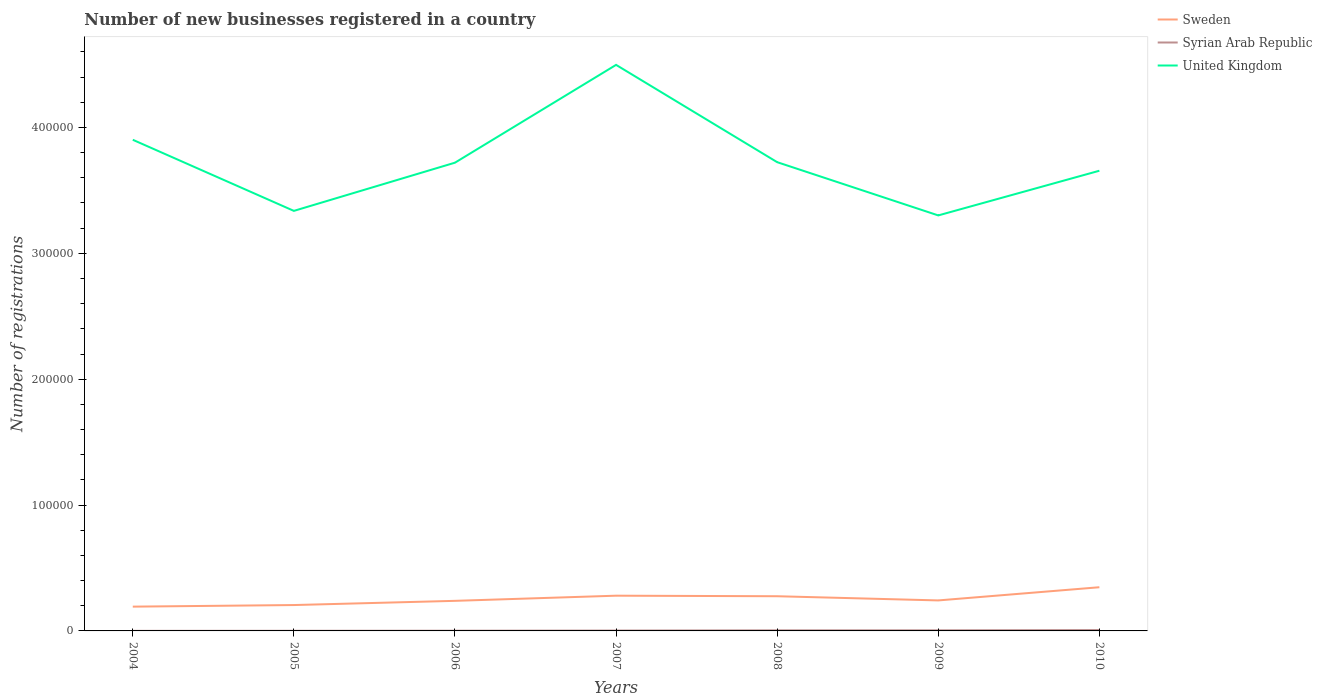Does the line corresponding to United Kingdom intersect with the line corresponding to Syrian Arab Republic?
Your answer should be very brief. No. Across all years, what is the maximum number of new businesses registered in Syrian Arab Republic?
Ensure brevity in your answer.  59. In which year was the number of new businesses registered in Sweden maximum?
Offer a terse response. 2004. What is the total number of new businesses registered in Syrian Arab Republic in the graph?
Your answer should be compact. -301. What is the difference between the highest and the second highest number of new businesses registered in United Kingdom?
Your answer should be very brief. 1.20e+05. What is the difference between the highest and the lowest number of new businesses registered in Sweden?
Provide a short and direct response. 3. How many lines are there?
Make the answer very short. 3. How many years are there in the graph?
Your answer should be compact. 7. What is the difference between two consecutive major ticks on the Y-axis?
Offer a terse response. 1.00e+05. Does the graph contain grids?
Offer a terse response. No. How many legend labels are there?
Your answer should be very brief. 3. What is the title of the graph?
Offer a terse response. Number of new businesses registered in a country. What is the label or title of the Y-axis?
Your answer should be compact. Number of registrations. What is the Number of registrations in Sweden in 2004?
Your answer should be compact. 1.93e+04. What is the Number of registrations of Syrian Arab Republic in 2004?
Ensure brevity in your answer.  59. What is the Number of registrations in United Kingdom in 2004?
Your answer should be compact. 3.90e+05. What is the Number of registrations of Sweden in 2005?
Keep it short and to the point. 2.06e+04. What is the Number of registrations of Syrian Arab Republic in 2005?
Provide a succinct answer. 114. What is the Number of registrations in United Kingdom in 2005?
Offer a very short reply. 3.34e+05. What is the Number of registrations of Sweden in 2006?
Your response must be concise. 2.39e+04. What is the Number of registrations in Syrian Arab Republic in 2006?
Give a very brief answer. 171. What is the Number of registrations of United Kingdom in 2006?
Offer a terse response. 3.72e+05. What is the Number of registrations of Sweden in 2007?
Your response must be concise. 2.80e+04. What is the Number of registrations of Syrian Arab Republic in 2007?
Offer a very short reply. 296. What is the Number of registrations of United Kingdom in 2007?
Your answer should be very brief. 4.50e+05. What is the Number of registrations in Sweden in 2008?
Ensure brevity in your answer.  2.76e+04. What is the Number of registrations of Syrian Arab Republic in 2008?
Your answer should be compact. 472. What is the Number of registrations in United Kingdom in 2008?
Your answer should be very brief. 3.72e+05. What is the Number of registrations of Sweden in 2009?
Your answer should be very brief. 2.42e+04. What is the Number of registrations of United Kingdom in 2009?
Provide a succinct answer. 3.30e+05. What is the Number of registrations in Sweden in 2010?
Offer a terse response. 3.47e+04. What is the Number of registrations in Syrian Arab Republic in 2010?
Your answer should be very brief. 713. What is the Number of registrations of United Kingdom in 2010?
Give a very brief answer. 3.66e+05. Across all years, what is the maximum Number of registrations in Sweden?
Offer a terse response. 3.47e+04. Across all years, what is the maximum Number of registrations of Syrian Arab Republic?
Offer a very short reply. 713. Across all years, what is the maximum Number of registrations in United Kingdom?
Provide a succinct answer. 4.50e+05. Across all years, what is the minimum Number of registrations of Sweden?
Provide a short and direct response. 1.93e+04. Across all years, what is the minimum Number of registrations in Syrian Arab Republic?
Your answer should be compact. 59. Across all years, what is the minimum Number of registrations of United Kingdom?
Provide a succinct answer. 3.30e+05. What is the total Number of registrations of Sweden in the graph?
Your answer should be very brief. 1.78e+05. What is the total Number of registrations of Syrian Arab Republic in the graph?
Your response must be concise. 2325. What is the total Number of registrations of United Kingdom in the graph?
Your response must be concise. 2.61e+06. What is the difference between the Number of registrations of Sweden in 2004 and that in 2005?
Your response must be concise. -1273. What is the difference between the Number of registrations in Syrian Arab Republic in 2004 and that in 2005?
Your answer should be compact. -55. What is the difference between the Number of registrations in United Kingdom in 2004 and that in 2005?
Offer a terse response. 5.65e+04. What is the difference between the Number of registrations in Sweden in 2004 and that in 2006?
Provide a short and direct response. -4606. What is the difference between the Number of registrations of Syrian Arab Republic in 2004 and that in 2006?
Offer a very short reply. -112. What is the difference between the Number of registrations of United Kingdom in 2004 and that in 2006?
Provide a short and direct response. 1.82e+04. What is the difference between the Number of registrations of Sweden in 2004 and that in 2007?
Make the answer very short. -8709. What is the difference between the Number of registrations in Syrian Arab Republic in 2004 and that in 2007?
Your answer should be very brief. -237. What is the difference between the Number of registrations in United Kingdom in 2004 and that in 2007?
Keep it short and to the point. -5.95e+04. What is the difference between the Number of registrations of Sweden in 2004 and that in 2008?
Give a very brief answer. -8267. What is the difference between the Number of registrations of Syrian Arab Republic in 2004 and that in 2008?
Make the answer very short. -413. What is the difference between the Number of registrations of United Kingdom in 2004 and that in 2008?
Your answer should be very brief. 1.78e+04. What is the difference between the Number of registrations of Sweden in 2004 and that in 2009?
Ensure brevity in your answer.  -4940. What is the difference between the Number of registrations of Syrian Arab Republic in 2004 and that in 2009?
Ensure brevity in your answer.  -441. What is the difference between the Number of registrations in United Kingdom in 2004 and that in 2009?
Your answer should be very brief. 6.01e+04. What is the difference between the Number of registrations in Sweden in 2004 and that in 2010?
Offer a terse response. -1.54e+04. What is the difference between the Number of registrations in Syrian Arab Republic in 2004 and that in 2010?
Ensure brevity in your answer.  -654. What is the difference between the Number of registrations of United Kingdom in 2004 and that in 2010?
Offer a terse response. 2.46e+04. What is the difference between the Number of registrations of Sweden in 2005 and that in 2006?
Keep it short and to the point. -3333. What is the difference between the Number of registrations in Syrian Arab Republic in 2005 and that in 2006?
Keep it short and to the point. -57. What is the difference between the Number of registrations of United Kingdom in 2005 and that in 2006?
Provide a short and direct response. -3.83e+04. What is the difference between the Number of registrations in Sweden in 2005 and that in 2007?
Your answer should be compact. -7436. What is the difference between the Number of registrations of Syrian Arab Republic in 2005 and that in 2007?
Ensure brevity in your answer.  -182. What is the difference between the Number of registrations in United Kingdom in 2005 and that in 2007?
Provide a succinct answer. -1.16e+05. What is the difference between the Number of registrations of Sweden in 2005 and that in 2008?
Your answer should be very brief. -6994. What is the difference between the Number of registrations of Syrian Arab Republic in 2005 and that in 2008?
Offer a terse response. -358. What is the difference between the Number of registrations of United Kingdom in 2005 and that in 2008?
Your response must be concise. -3.87e+04. What is the difference between the Number of registrations in Sweden in 2005 and that in 2009?
Make the answer very short. -3667. What is the difference between the Number of registrations in Syrian Arab Republic in 2005 and that in 2009?
Your response must be concise. -386. What is the difference between the Number of registrations in United Kingdom in 2005 and that in 2009?
Your response must be concise. 3600. What is the difference between the Number of registrations in Sweden in 2005 and that in 2010?
Ensure brevity in your answer.  -1.41e+04. What is the difference between the Number of registrations in Syrian Arab Republic in 2005 and that in 2010?
Your answer should be very brief. -599. What is the difference between the Number of registrations in United Kingdom in 2005 and that in 2010?
Your answer should be very brief. -3.19e+04. What is the difference between the Number of registrations of Sweden in 2006 and that in 2007?
Your response must be concise. -4103. What is the difference between the Number of registrations in Syrian Arab Republic in 2006 and that in 2007?
Keep it short and to the point. -125. What is the difference between the Number of registrations in United Kingdom in 2006 and that in 2007?
Your response must be concise. -7.77e+04. What is the difference between the Number of registrations in Sweden in 2006 and that in 2008?
Make the answer very short. -3661. What is the difference between the Number of registrations of Syrian Arab Republic in 2006 and that in 2008?
Give a very brief answer. -301. What is the difference between the Number of registrations of United Kingdom in 2006 and that in 2008?
Your answer should be very brief. -400. What is the difference between the Number of registrations of Sweden in 2006 and that in 2009?
Offer a terse response. -334. What is the difference between the Number of registrations in Syrian Arab Republic in 2006 and that in 2009?
Give a very brief answer. -329. What is the difference between the Number of registrations of United Kingdom in 2006 and that in 2009?
Provide a succinct answer. 4.19e+04. What is the difference between the Number of registrations in Sweden in 2006 and that in 2010?
Offer a very short reply. -1.08e+04. What is the difference between the Number of registrations of Syrian Arab Republic in 2006 and that in 2010?
Keep it short and to the point. -542. What is the difference between the Number of registrations in United Kingdom in 2006 and that in 2010?
Your answer should be compact. 6400. What is the difference between the Number of registrations in Sweden in 2007 and that in 2008?
Keep it short and to the point. 442. What is the difference between the Number of registrations in Syrian Arab Republic in 2007 and that in 2008?
Your answer should be compact. -176. What is the difference between the Number of registrations of United Kingdom in 2007 and that in 2008?
Your response must be concise. 7.73e+04. What is the difference between the Number of registrations of Sweden in 2007 and that in 2009?
Your answer should be very brief. 3769. What is the difference between the Number of registrations of Syrian Arab Republic in 2007 and that in 2009?
Your response must be concise. -204. What is the difference between the Number of registrations in United Kingdom in 2007 and that in 2009?
Give a very brief answer. 1.20e+05. What is the difference between the Number of registrations in Sweden in 2007 and that in 2010?
Offer a terse response. -6711. What is the difference between the Number of registrations of Syrian Arab Republic in 2007 and that in 2010?
Keep it short and to the point. -417. What is the difference between the Number of registrations in United Kingdom in 2007 and that in 2010?
Keep it short and to the point. 8.41e+04. What is the difference between the Number of registrations in Sweden in 2008 and that in 2009?
Give a very brief answer. 3327. What is the difference between the Number of registrations of United Kingdom in 2008 and that in 2009?
Give a very brief answer. 4.23e+04. What is the difference between the Number of registrations in Sweden in 2008 and that in 2010?
Offer a terse response. -7153. What is the difference between the Number of registrations in Syrian Arab Republic in 2008 and that in 2010?
Your answer should be very brief. -241. What is the difference between the Number of registrations of United Kingdom in 2008 and that in 2010?
Ensure brevity in your answer.  6800. What is the difference between the Number of registrations of Sweden in 2009 and that in 2010?
Your answer should be very brief. -1.05e+04. What is the difference between the Number of registrations in Syrian Arab Republic in 2009 and that in 2010?
Provide a short and direct response. -213. What is the difference between the Number of registrations of United Kingdom in 2009 and that in 2010?
Give a very brief answer. -3.55e+04. What is the difference between the Number of registrations in Sweden in 2004 and the Number of registrations in Syrian Arab Republic in 2005?
Make the answer very short. 1.92e+04. What is the difference between the Number of registrations in Sweden in 2004 and the Number of registrations in United Kingdom in 2005?
Make the answer very short. -3.14e+05. What is the difference between the Number of registrations in Syrian Arab Republic in 2004 and the Number of registrations in United Kingdom in 2005?
Offer a very short reply. -3.34e+05. What is the difference between the Number of registrations in Sweden in 2004 and the Number of registrations in Syrian Arab Republic in 2006?
Your answer should be compact. 1.91e+04. What is the difference between the Number of registrations in Sweden in 2004 and the Number of registrations in United Kingdom in 2006?
Offer a very short reply. -3.53e+05. What is the difference between the Number of registrations in Syrian Arab Republic in 2004 and the Number of registrations in United Kingdom in 2006?
Your answer should be very brief. -3.72e+05. What is the difference between the Number of registrations in Sweden in 2004 and the Number of registrations in Syrian Arab Republic in 2007?
Your answer should be compact. 1.90e+04. What is the difference between the Number of registrations of Sweden in 2004 and the Number of registrations of United Kingdom in 2007?
Give a very brief answer. -4.30e+05. What is the difference between the Number of registrations of Syrian Arab Republic in 2004 and the Number of registrations of United Kingdom in 2007?
Offer a terse response. -4.50e+05. What is the difference between the Number of registrations in Sweden in 2004 and the Number of registrations in Syrian Arab Republic in 2008?
Ensure brevity in your answer.  1.88e+04. What is the difference between the Number of registrations in Sweden in 2004 and the Number of registrations in United Kingdom in 2008?
Your answer should be very brief. -3.53e+05. What is the difference between the Number of registrations in Syrian Arab Republic in 2004 and the Number of registrations in United Kingdom in 2008?
Offer a very short reply. -3.72e+05. What is the difference between the Number of registrations of Sweden in 2004 and the Number of registrations of Syrian Arab Republic in 2009?
Provide a succinct answer. 1.88e+04. What is the difference between the Number of registrations in Sweden in 2004 and the Number of registrations in United Kingdom in 2009?
Offer a terse response. -3.11e+05. What is the difference between the Number of registrations of Syrian Arab Republic in 2004 and the Number of registrations of United Kingdom in 2009?
Provide a succinct answer. -3.30e+05. What is the difference between the Number of registrations in Sweden in 2004 and the Number of registrations in Syrian Arab Republic in 2010?
Make the answer very short. 1.86e+04. What is the difference between the Number of registrations of Sweden in 2004 and the Number of registrations of United Kingdom in 2010?
Keep it short and to the point. -3.46e+05. What is the difference between the Number of registrations of Syrian Arab Republic in 2004 and the Number of registrations of United Kingdom in 2010?
Offer a terse response. -3.66e+05. What is the difference between the Number of registrations of Sweden in 2005 and the Number of registrations of Syrian Arab Republic in 2006?
Offer a terse response. 2.04e+04. What is the difference between the Number of registrations of Sweden in 2005 and the Number of registrations of United Kingdom in 2006?
Offer a terse response. -3.51e+05. What is the difference between the Number of registrations in Syrian Arab Republic in 2005 and the Number of registrations in United Kingdom in 2006?
Make the answer very short. -3.72e+05. What is the difference between the Number of registrations in Sweden in 2005 and the Number of registrations in Syrian Arab Republic in 2007?
Keep it short and to the point. 2.03e+04. What is the difference between the Number of registrations in Sweden in 2005 and the Number of registrations in United Kingdom in 2007?
Make the answer very short. -4.29e+05. What is the difference between the Number of registrations in Syrian Arab Republic in 2005 and the Number of registrations in United Kingdom in 2007?
Provide a succinct answer. -4.50e+05. What is the difference between the Number of registrations of Sweden in 2005 and the Number of registrations of Syrian Arab Republic in 2008?
Your response must be concise. 2.01e+04. What is the difference between the Number of registrations of Sweden in 2005 and the Number of registrations of United Kingdom in 2008?
Give a very brief answer. -3.52e+05. What is the difference between the Number of registrations in Syrian Arab Republic in 2005 and the Number of registrations in United Kingdom in 2008?
Offer a terse response. -3.72e+05. What is the difference between the Number of registrations of Sweden in 2005 and the Number of registrations of Syrian Arab Republic in 2009?
Make the answer very short. 2.01e+04. What is the difference between the Number of registrations in Sweden in 2005 and the Number of registrations in United Kingdom in 2009?
Provide a succinct answer. -3.10e+05. What is the difference between the Number of registrations in Syrian Arab Republic in 2005 and the Number of registrations in United Kingdom in 2009?
Ensure brevity in your answer.  -3.30e+05. What is the difference between the Number of registrations in Sweden in 2005 and the Number of registrations in Syrian Arab Republic in 2010?
Offer a terse response. 1.98e+04. What is the difference between the Number of registrations in Sweden in 2005 and the Number of registrations in United Kingdom in 2010?
Offer a terse response. -3.45e+05. What is the difference between the Number of registrations in Syrian Arab Republic in 2005 and the Number of registrations in United Kingdom in 2010?
Offer a very short reply. -3.65e+05. What is the difference between the Number of registrations in Sweden in 2006 and the Number of registrations in Syrian Arab Republic in 2007?
Your answer should be very brief. 2.36e+04. What is the difference between the Number of registrations in Sweden in 2006 and the Number of registrations in United Kingdom in 2007?
Keep it short and to the point. -4.26e+05. What is the difference between the Number of registrations in Syrian Arab Republic in 2006 and the Number of registrations in United Kingdom in 2007?
Provide a succinct answer. -4.50e+05. What is the difference between the Number of registrations of Sweden in 2006 and the Number of registrations of Syrian Arab Republic in 2008?
Give a very brief answer. 2.34e+04. What is the difference between the Number of registrations in Sweden in 2006 and the Number of registrations in United Kingdom in 2008?
Your answer should be compact. -3.49e+05. What is the difference between the Number of registrations in Syrian Arab Republic in 2006 and the Number of registrations in United Kingdom in 2008?
Ensure brevity in your answer.  -3.72e+05. What is the difference between the Number of registrations of Sweden in 2006 and the Number of registrations of Syrian Arab Republic in 2009?
Make the answer very short. 2.34e+04. What is the difference between the Number of registrations of Sweden in 2006 and the Number of registrations of United Kingdom in 2009?
Your response must be concise. -3.06e+05. What is the difference between the Number of registrations in Syrian Arab Republic in 2006 and the Number of registrations in United Kingdom in 2009?
Provide a short and direct response. -3.30e+05. What is the difference between the Number of registrations of Sweden in 2006 and the Number of registrations of Syrian Arab Republic in 2010?
Ensure brevity in your answer.  2.32e+04. What is the difference between the Number of registrations of Sweden in 2006 and the Number of registrations of United Kingdom in 2010?
Keep it short and to the point. -3.42e+05. What is the difference between the Number of registrations in Syrian Arab Republic in 2006 and the Number of registrations in United Kingdom in 2010?
Provide a short and direct response. -3.65e+05. What is the difference between the Number of registrations in Sweden in 2007 and the Number of registrations in Syrian Arab Republic in 2008?
Your answer should be compact. 2.75e+04. What is the difference between the Number of registrations of Sweden in 2007 and the Number of registrations of United Kingdom in 2008?
Offer a terse response. -3.44e+05. What is the difference between the Number of registrations of Syrian Arab Republic in 2007 and the Number of registrations of United Kingdom in 2008?
Your answer should be compact. -3.72e+05. What is the difference between the Number of registrations of Sweden in 2007 and the Number of registrations of Syrian Arab Republic in 2009?
Provide a short and direct response. 2.75e+04. What is the difference between the Number of registrations of Sweden in 2007 and the Number of registrations of United Kingdom in 2009?
Provide a succinct answer. -3.02e+05. What is the difference between the Number of registrations of Syrian Arab Republic in 2007 and the Number of registrations of United Kingdom in 2009?
Offer a terse response. -3.30e+05. What is the difference between the Number of registrations of Sweden in 2007 and the Number of registrations of Syrian Arab Republic in 2010?
Offer a very short reply. 2.73e+04. What is the difference between the Number of registrations of Sweden in 2007 and the Number of registrations of United Kingdom in 2010?
Provide a short and direct response. -3.38e+05. What is the difference between the Number of registrations of Syrian Arab Republic in 2007 and the Number of registrations of United Kingdom in 2010?
Give a very brief answer. -3.65e+05. What is the difference between the Number of registrations in Sweden in 2008 and the Number of registrations in Syrian Arab Republic in 2009?
Provide a succinct answer. 2.71e+04. What is the difference between the Number of registrations of Sweden in 2008 and the Number of registrations of United Kingdom in 2009?
Your answer should be very brief. -3.03e+05. What is the difference between the Number of registrations of Syrian Arab Republic in 2008 and the Number of registrations of United Kingdom in 2009?
Your answer should be compact. -3.30e+05. What is the difference between the Number of registrations of Sweden in 2008 and the Number of registrations of Syrian Arab Republic in 2010?
Offer a very short reply. 2.68e+04. What is the difference between the Number of registrations of Sweden in 2008 and the Number of registrations of United Kingdom in 2010?
Your response must be concise. -3.38e+05. What is the difference between the Number of registrations of Syrian Arab Republic in 2008 and the Number of registrations of United Kingdom in 2010?
Keep it short and to the point. -3.65e+05. What is the difference between the Number of registrations in Sweden in 2009 and the Number of registrations in Syrian Arab Republic in 2010?
Give a very brief answer. 2.35e+04. What is the difference between the Number of registrations of Sweden in 2009 and the Number of registrations of United Kingdom in 2010?
Provide a short and direct response. -3.41e+05. What is the difference between the Number of registrations of Syrian Arab Republic in 2009 and the Number of registrations of United Kingdom in 2010?
Give a very brief answer. -3.65e+05. What is the average Number of registrations of Sweden per year?
Your response must be concise. 2.55e+04. What is the average Number of registrations in Syrian Arab Republic per year?
Provide a succinct answer. 332.14. What is the average Number of registrations of United Kingdom per year?
Ensure brevity in your answer.  3.73e+05. In the year 2004, what is the difference between the Number of registrations in Sweden and Number of registrations in Syrian Arab Republic?
Offer a very short reply. 1.92e+04. In the year 2004, what is the difference between the Number of registrations in Sweden and Number of registrations in United Kingdom?
Give a very brief answer. -3.71e+05. In the year 2004, what is the difference between the Number of registrations of Syrian Arab Republic and Number of registrations of United Kingdom?
Provide a succinct answer. -3.90e+05. In the year 2005, what is the difference between the Number of registrations of Sweden and Number of registrations of Syrian Arab Republic?
Offer a terse response. 2.04e+04. In the year 2005, what is the difference between the Number of registrations in Sweden and Number of registrations in United Kingdom?
Give a very brief answer. -3.13e+05. In the year 2005, what is the difference between the Number of registrations of Syrian Arab Republic and Number of registrations of United Kingdom?
Keep it short and to the point. -3.34e+05. In the year 2006, what is the difference between the Number of registrations of Sweden and Number of registrations of Syrian Arab Republic?
Make the answer very short. 2.37e+04. In the year 2006, what is the difference between the Number of registrations of Sweden and Number of registrations of United Kingdom?
Ensure brevity in your answer.  -3.48e+05. In the year 2006, what is the difference between the Number of registrations in Syrian Arab Republic and Number of registrations in United Kingdom?
Keep it short and to the point. -3.72e+05. In the year 2007, what is the difference between the Number of registrations of Sweden and Number of registrations of Syrian Arab Republic?
Offer a terse response. 2.77e+04. In the year 2007, what is the difference between the Number of registrations of Sweden and Number of registrations of United Kingdom?
Keep it short and to the point. -4.22e+05. In the year 2007, what is the difference between the Number of registrations of Syrian Arab Republic and Number of registrations of United Kingdom?
Provide a short and direct response. -4.49e+05. In the year 2008, what is the difference between the Number of registrations in Sweden and Number of registrations in Syrian Arab Republic?
Offer a terse response. 2.71e+04. In the year 2008, what is the difference between the Number of registrations of Sweden and Number of registrations of United Kingdom?
Give a very brief answer. -3.45e+05. In the year 2008, what is the difference between the Number of registrations of Syrian Arab Republic and Number of registrations of United Kingdom?
Your answer should be very brief. -3.72e+05. In the year 2009, what is the difference between the Number of registrations in Sweden and Number of registrations in Syrian Arab Republic?
Your answer should be compact. 2.37e+04. In the year 2009, what is the difference between the Number of registrations in Sweden and Number of registrations in United Kingdom?
Make the answer very short. -3.06e+05. In the year 2009, what is the difference between the Number of registrations in Syrian Arab Republic and Number of registrations in United Kingdom?
Your answer should be very brief. -3.30e+05. In the year 2010, what is the difference between the Number of registrations in Sweden and Number of registrations in Syrian Arab Republic?
Your response must be concise. 3.40e+04. In the year 2010, what is the difference between the Number of registrations in Sweden and Number of registrations in United Kingdom?
Keep it short and to the point. -3.31e+05. In the year 2010, what is the difference between the Number of registrations of Syrian Arab Republic and Number of registrations of United Kingdom?
Keep it short and to the point. -3.65e+05. What is the ratio of the Number of registrations of Sweden in 2004 to that in 2005?
Your response must be concise. 0.94. What is the ratio of the Number of registrations in Syrian Arab Republic in 2004 to that in 2005?
Make the answer very short. 0.52. What is the ratio of the Number of registrations in United Kingdom in 2004 to that in 2005?
Ensure brevity in your answer.  1.17. What is the ratio of the Number of registrations in Sweden in 2004 to that in 2006?
Keep it short and to the point. 0.81. What is the ratio of the Number of registrations of Syrian Arab Republic in 2004 to that in 2006?
Make the answer very short. 0.34. What is the ratio of the Number of registrations in United Kingdom in 2004 to that in 2006?
Give a very brief answer. 1.05. What is the ratio of the Number of registrations in Sweden in 2004 to that in 2007?
Provide a succinct answer. 0.69. What is the ratio of the Number of registrations in Syrian Arab Republic in 2004 to that in 2007?
Make the answer very short. 0.2. What is the ratio of the Number of registrations in United Kingdom in 2004 to that in 2007?
Offer a terse response. 0.87. What is the ratio of the Number of registrations of Sweden in 2004 to that in 2008?
Ensure brevity in your answer.  0.7. What is the ratio of the Number of registrations in Syrian Arab Republic in 2004 to that in 2008?
Make the answer very short. 0.12. What is the ratio of the Number of registrations in United Kingdom in 2004 to that in 2008?
Provide a short and direct response. 1.05. What is the ratio of the Number of registrations in Sweden in 2004 to that in 2009?
Keep it short and to the point. 0.8. What is the ratio of the Number of registrations of Syrian Arab Republic in 2004 to that in 2009?
Your answer should be compact. 0.12. What is the ratio of the Number of registrations in United Kingdom in 2004 to that in 2009?
Give a very brief answer. 1.18. What is the ratio of the Number of registrations of Sweden in 2004 to that in 2010?
Give a very brief answer. 0.56. What is the ratio of the Number of registrations of Syrian Arab Republic in 2004 to that in 2010?
Your answer should be compact. 0.08. What is the ratio of the Number of registrations of United Kingdom in 2004 to that in 2010?
Your answer should be compact. 1.07. What is the ratio of the Number of registrations in Sweden in 2005 to that in 2006?
Provide a succinct answer. 0.86. What is the ratio of the Number of registrations in United Kingdom in 2005 to that in 2006?
Offer a terse response. 0.9. What is the ratio of the Number of registrations in Sweden in 2005 to that in 2007?
Offer a terse response. 0.73. What is the ratio of the Number of registrations in Syrian Arab Republic in 2005 to that in 2007?
Your response must be concise. 0.39. What is the ratio of the Number of registrations in United Kingdom in 2005 to that in 2007?
Provide a succinct answer. 0.74. What is the ratio of the Number of registrations in Sweden in 2005 to that in 2008?
Offer a terse response. 0.75. What is the ratio of the Number of registrations in Syrian Arab Republic in 2005 to that in 2008?
Keep it short and to the point. 0.24. What is the ratio of the Number of registrations in United Kingdom in 2005 to that in 2008?
Keep it short and to the point. 0.9. What is the ratio of the Number of registrations in Sweden in 2005 to that in 2009?
Provide a short and direct response. 0.85. What is the ratio of the Number of registrations in Syrian Arab Republic in 2005 to that in 2009?
Keep it short and to the point. 0.23. What is the ratio of the Number of registrations in United Kingdom in 2005 to that in 2009?
Make the answer very short. 1.01. What is the ratio of the Number of registrations in Sweden in 2005 to that in 2010?
Keep it short and to the point. 0.59. What is the ratio of the Number of registrations in Syrian Arab Republic in 2005 to that in 2010?
Your answer should be very brief. 0.16. What is the ratio of the Number of registrations in United Kingdom in 2005 to that in 2010?
Your response must be concise. 0.91. What is the ratio of the Number of registrations in Sweden in 2006 to that in 2007?
Provide a short and direct response. 0.85. What is the ratio of the Number of registrations of Syrian Arab Republic in 2006 to that in 2007?
Provide a succinct answer. 0.58. What is the ratio of the Number of registrations in United Kingdom in 2006 to that in 2007?
Provide a short and direct response. 0.83. What is the ratio of the Number of registrations in Sweden in 2006 to that in 2008?
Give a very brief answer. 0.87. What is the ratio of the Number of registrations in Syrian Arab Republic in 2006 to that in 2008?
Provide a short and direct response. 0.36. What is the ratio of the Number of registrations of United Kingdom in 2006 to that in 2008?
Offer a very short reply. 1. What is the ratio of the Number of registrations in Sweden in 2006 to that in 2009?
Your response must be concise. 0.99. What is the ratio of the Number of registrations in Syrian Arab Republic in 2006 to that in 2009?
Your answer should be very brief. 0.34. What is the ratio of the Number of registrations in United Kingdom in 2006 to that in 2009?
Your answer should be very brief. 1.13. What is the ratio of the Number of registrations of Sweden in 2006 to that in 2010?
Provide a succinct answer. 0.69. What is the ratio of the Number of registrations in Syrian Arab Republic in 2006 to that in 2010?
Provide a succinct answer. 0.24. What is the ratio of the Number of registrations in United Kingdom in 2006 to that in 2010?
Keep it short and to the point. 1.02. What is the ratio of the Number of registrations of Sweden in 2007 to that in 2008?
Keep it short and to the point. 1.02. What is the ratio of the Number of registrations of Syrian Arab Republic in 2007 to that in 2008?
Your answer should be compact. 0.63. What is the ratio of the Number of registrations in United Kingdom in 2007 to that in 2008?
Provide a succinct answer. 1.21. What is the ratio of the Number of registrations in Sweden in 2007 to that in 2009?
Your answer should be compact. 1.16. What is the ratio of the Number of registrations of Syrian Arab Republic in 2007 to that in 2009?
Provide a short and direct response. 0.59. What is the ratio of the Number of registrations in United Kingdom in 2007 to that in 2009?
Provide a short and direct response. 1.36. What is the ratio of the Number of registrations of Sweden in 2007 to that in 2010?
Offer a terse response. 0.81. What is the ratio of the Number of registrations in Syrian Arab Republic in 2007 to that in 2010?
Provide a short and direct response. 0.42. What is the ratio of the Number of registrations in United Kingdom in 2007 to that in 2010?
Make the answer very short. 1.23. What is the ratio of the Number of registrations of Sweden in 2008 to that in 2009?
Offer a very short reply. 1.14. What is the ratio of the Number of registrations of Syrian Arab Republic in 2008 to that in 2009?
Provide a short and direct response. 0.94. What is the ratio of the Number of registrations in United Kingdom in 2008 to that in 2009?
Offer a terse response. 1.13. What is the ratio of the Number of registrations in Sweden in 2008 to that in 2010?
Offer a terse response. 0.79. What is the ratio of the Number of registrations of Syrian Arab Republic in 2008 to that in 2010?
Offer a terse response. 0.66. What is the ratio of the Number of registrations of United Kingdom in 2008 to that in 2010?
Offer a terse response. 1.02. What is the ratio of the Number of registrations of Sweden in 2009 to that in 2010?
Provide a short and direct response. 0.7. What is the ratio of the Number of registrations in Syrian Arab Republic in 2009 to that in 2010?
Your response must be concise. 0.7. What is the ratio of the Number of registrations in United Kingdom in 2009 to that in 2010?
Provide a short and direct response. 0.9. What is the difference between the highest and the second highest Number of registrations of Sweden?
Offer a terse response. 6711. What is the difference between the highest and the second highest Number of registrations in Syrian Arab Republic?
Your answer should be compact. 213. What is the difference between the highest and the second highest Number of registrations in United Kingdom?
Your answer should be compact. 5.95e+04. What is the difference between the highest and the lowest Number of registrations in Sweden?
Ensure brevity in your answer.  1.54e+04. What is the difference between the highest and the lowest Number of registrations in Syrian Arab Republic?
Provide a short and direct response. 654. What is the difference between the highest and the lowest Number of registrations of United Kingdom?
Give a very brief answer. 1.20e+05. 